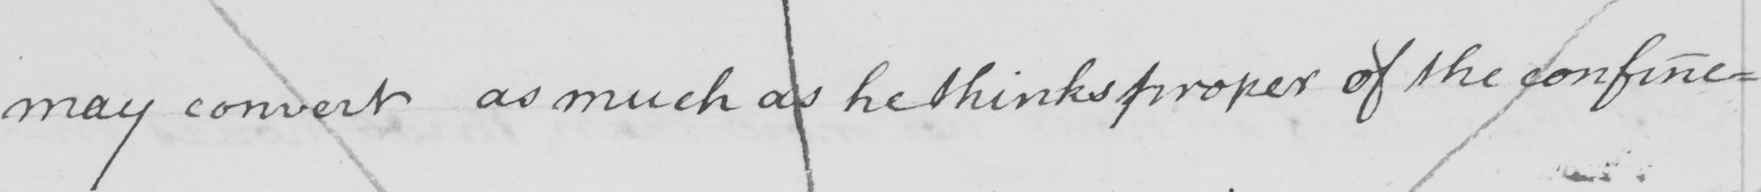What text is written in this handwritten line? may convert as much as he thinks proper of the confine= 